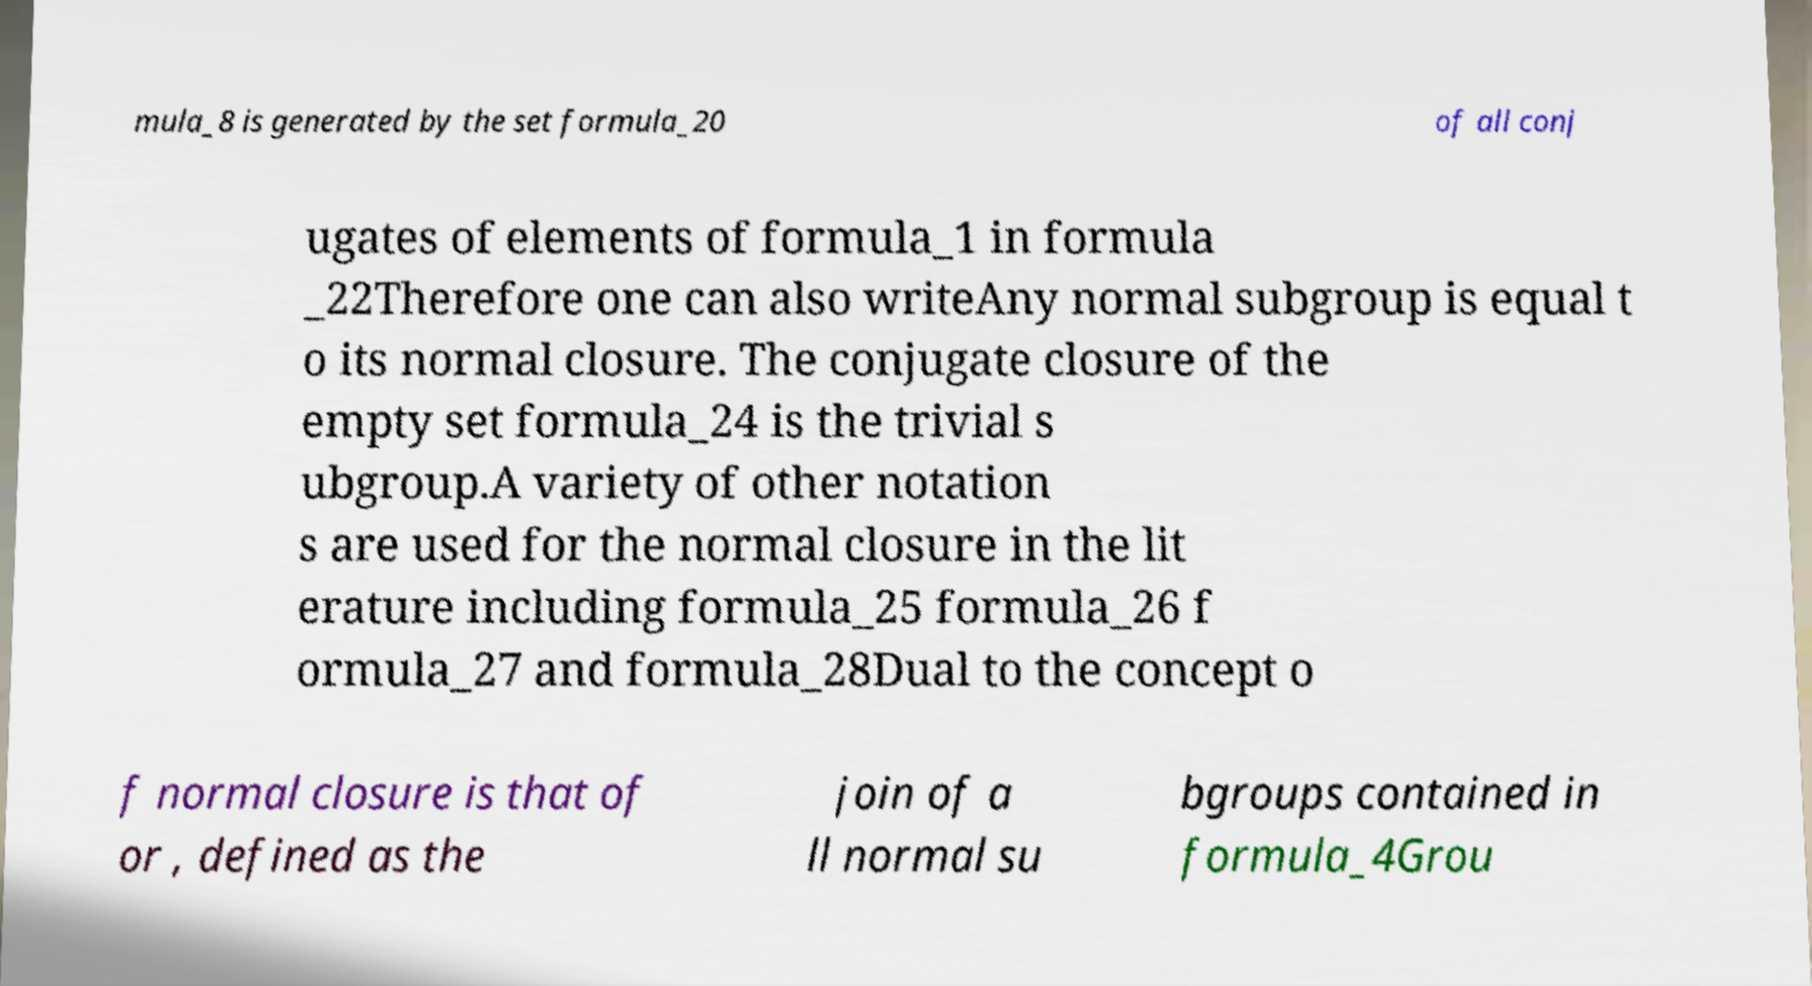I need the written content from this picture converted into text. Can you do that? mula_8 is generated by the set formula_20 of all conj ugates of elements of formula_1 in formula _22Therefore one can also writeAny normal subgroup is equal t o its normal closure. The conjugate closure of the empty set formula_24 is the trivial s ubgroup.A variety of other notation s are used for the normal closure in the lit erature including formula_25 formula_26 f ormula_27 and formula_28Dual to the concept o f normal closure is that of or , defined as the join of a ll normal su bgroups contained in formula_4Grou 